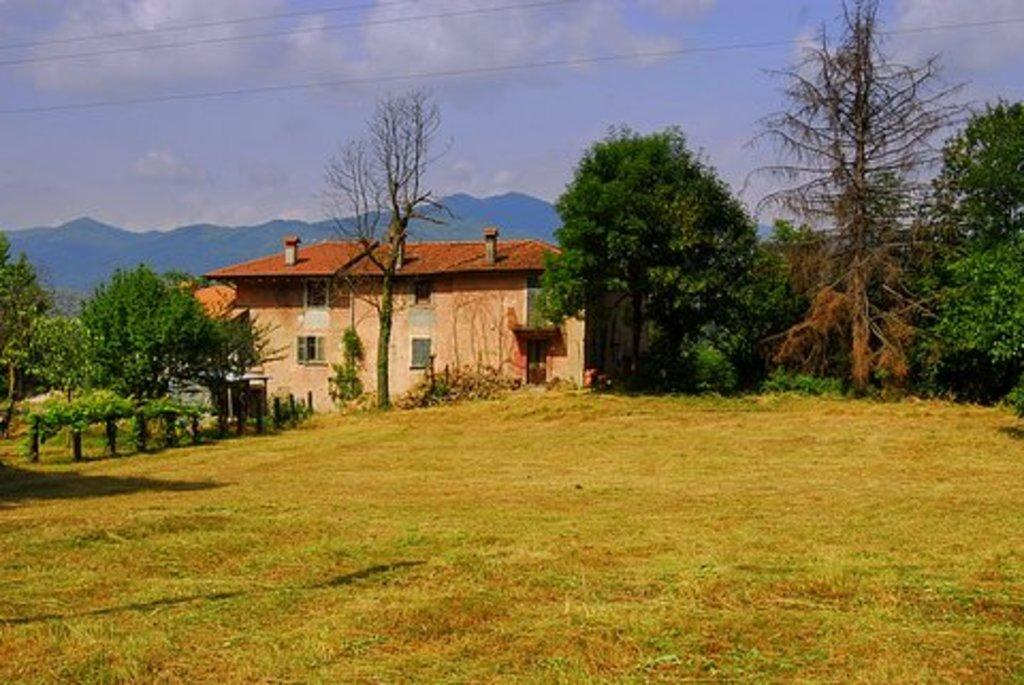What type of structure is visible in the image? There is a house in the image. What type of vegetation can be seen in the image? There are trees and grass in the image. What geographical feature is present in the image? There are hills in the image. How does the house show respect to the trees in the image? The house does not show respect to the trees in the image, as these concepts are not applicable to inanimate objects. 